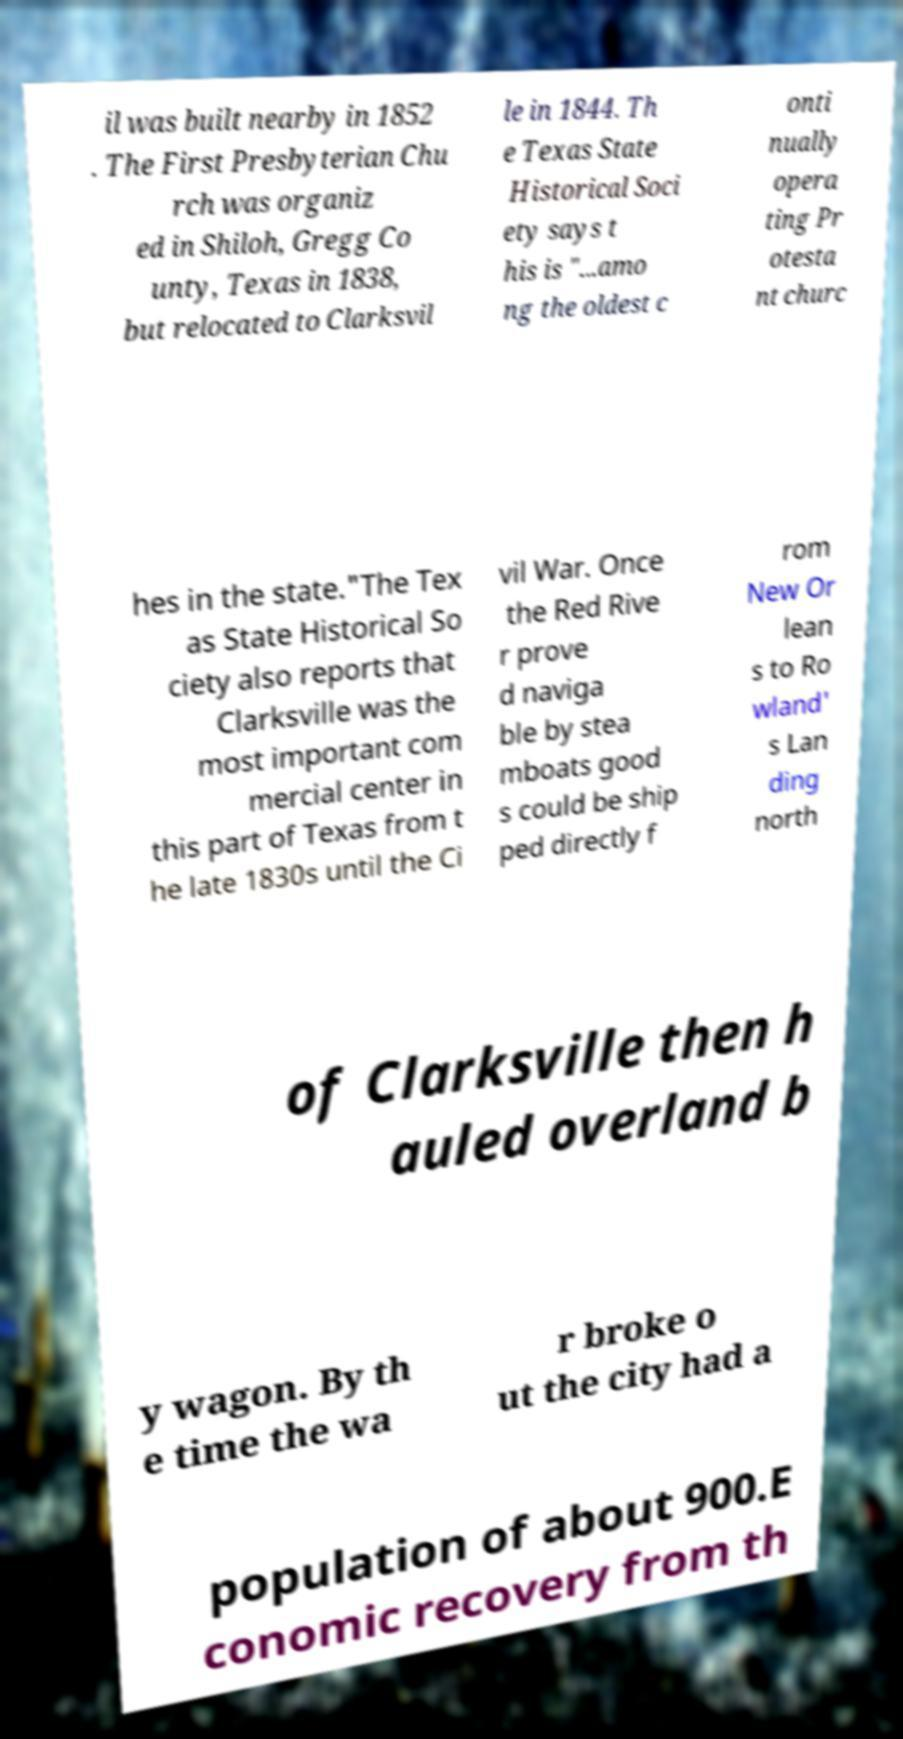Could you extract and type out the text from this image? il was built nearby in 1852 . The First Presbyterian Chu rch was organiz ed in Shiloh, Gregg Co unty, Texas in 1838, but relocated to Clarksvil le in 1844. Th e Texas State Historical Soci ety says t his is "...amo ng the oldest c onti nually opera ting Pr otesta nt churc hes in the state."The Tex as State Historical So ciety also reports that Clarksville was the most important com mercial center in this part of Texas from t he late 1830s until the Ci vil War. Once the Red Rive r prove d naviga ble by stea mboats good s could be ship ped directly f rom New Or lean s to Ro wland' s Lan ding north of Clarksville then h auled overland b y wagon. By th e time the wa r broke o ut the city had a population of about 900.E conomic recovery from th 